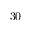<formula> <loc_0><loc_0><loc_500><loc_500>3 0</formula> 